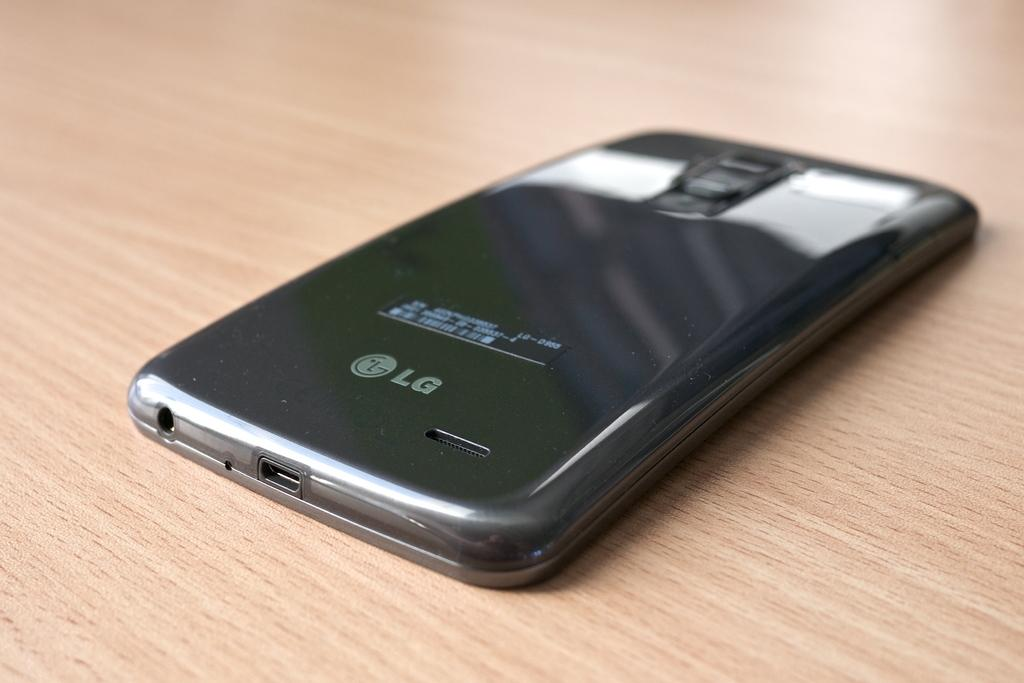<image>
Relay a brief, clear account of the picture shown. The black phone sitting face down on the table is a LG phone. 